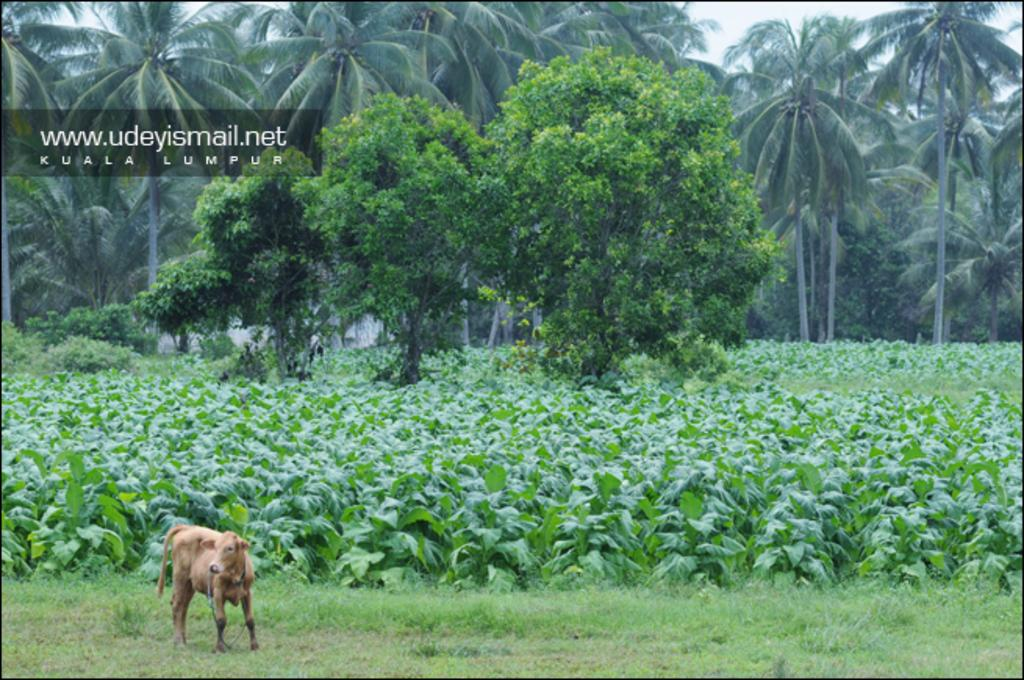What type of vegetation can be seen in the image? There are many trees and plants in the image. Can you describe the animal in the image? There is an animal in the image, but its specific characteristics are not mentioned in the facts. What is the terrain like in the image? There is a grassy land in the image. What part of the natural environment is visible in the image? The sky is visible in the image. What type of potato is being harvested by the family in the image? There is no family or potato present in the image; it features trees, plants, an animal, grassy land, and the sky. 